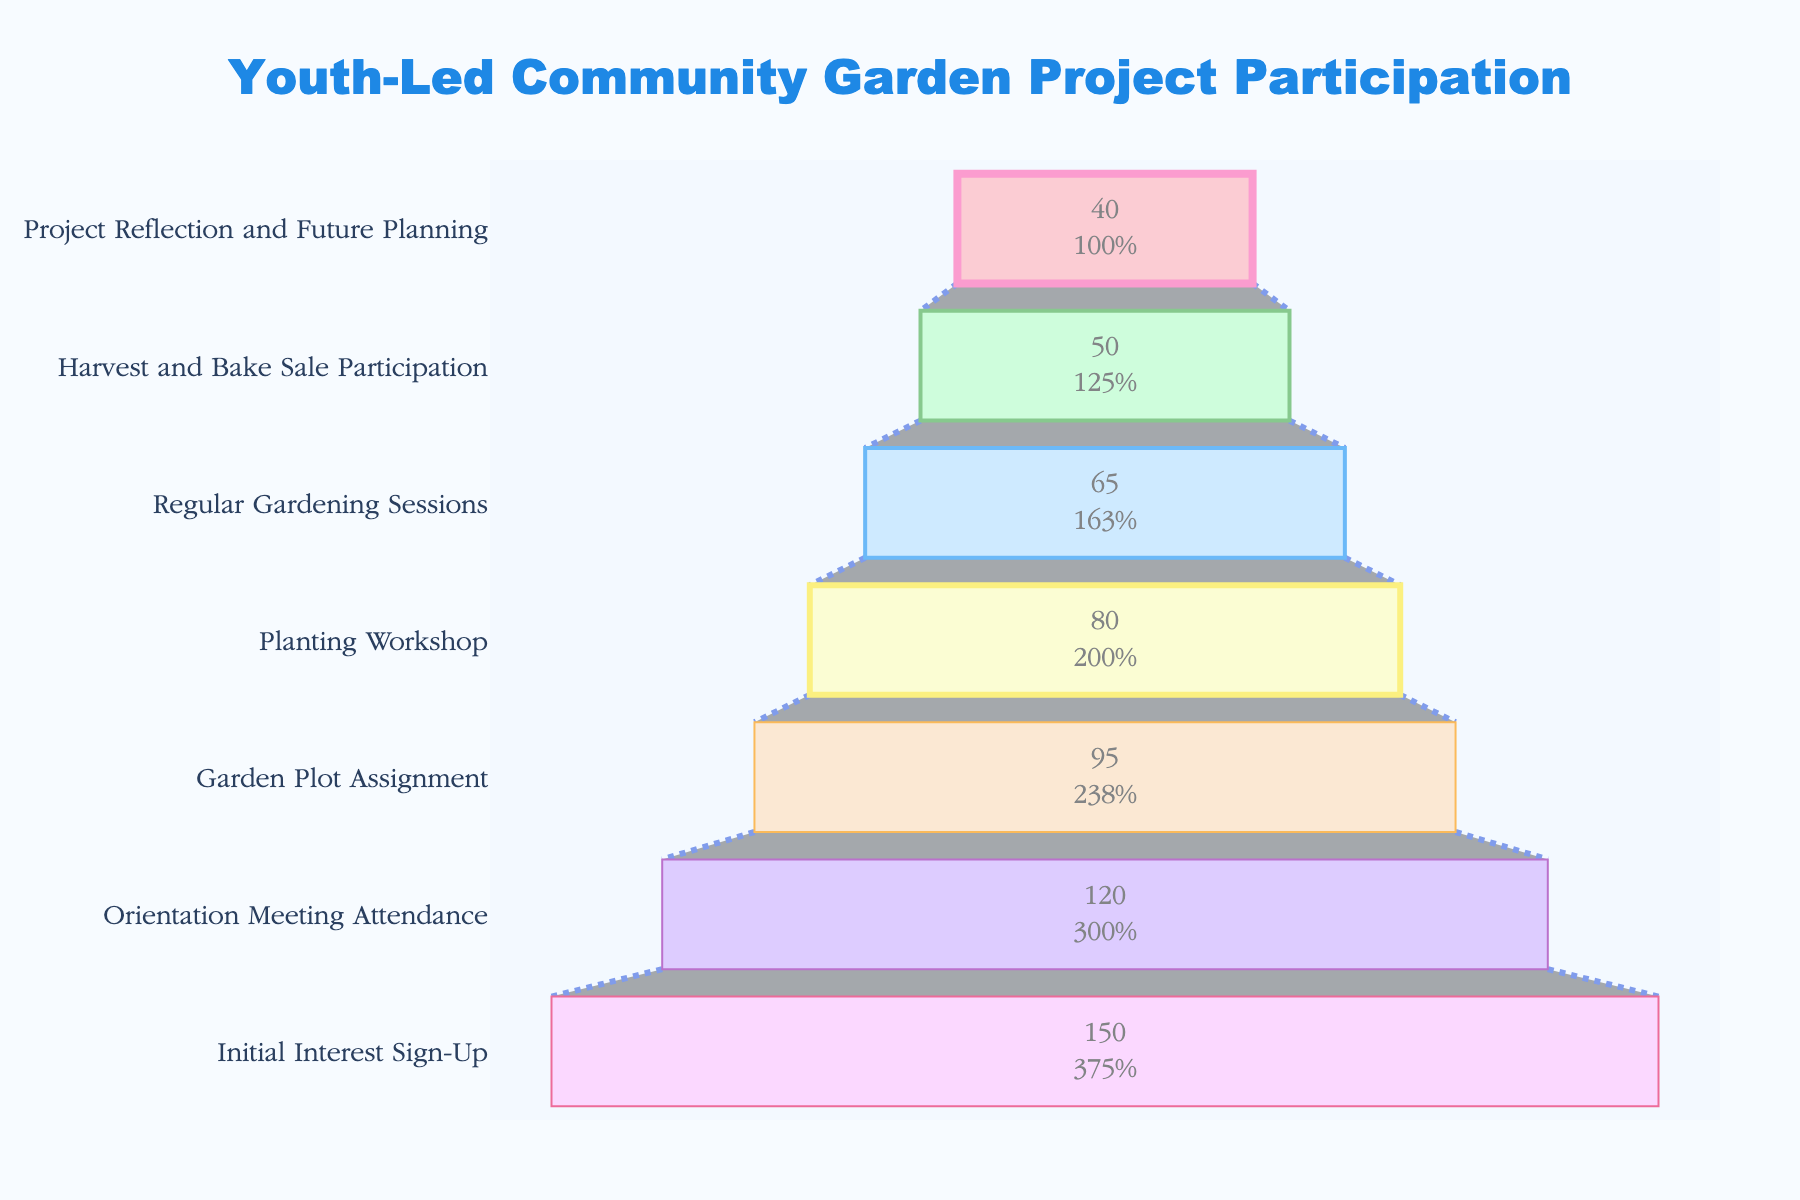What's the title of the chart? The title of the chart is prominently displayed at the top of the figure. It reads "Youth-Led Community Garden Project Participation".
Answer: "Youth-Led Community Garden Project Participation" How many participants attended the Orientation Meeting? The second stage from the top of the funnel chart shows the number of participants who attended the Orientation Meeting. It indicates 120 participants there.
Answer: 120 What is the percentage decrease in participants from the Orientation Meeting Attendance to the Garden Plot Assignment? First, find the number of participants at both stages: 120 (Orientation Meeting Attendance) and 95 (Garden Plot Assignment). The decrease is 120 - 95 = 25. To find the percentage decrease: (25/120) * 100 ≈ 20.83%.
Answer: ≈ 20.83% In which stage did the participation drop the most? By comparing the number of participants at each stage, the largest drop is observed from the Orientation Meeting Attendance (120 participants) to the Garden Plot Assignment (95 participants), a drop of 25 participants.
Answer: Orientation Meeting Attendance to Garden Plot Assignment Which stages have fewer than 70 participants? According to the figure, stages with fewer than 70 participants are Regular Gardening Sessions (65 participants), Harvest and Bake Sale Participation (50 participants), and Project Reflection and Future Planning (40 participants).
Answer: Regular Gardening Sessions, Harvest and Bake Sale Participation, Project Reflection and Future Planning What stage immediately follows the Initial Interest Sign-Up, and how many participants were there? The stage that follows Initial Interest Sign-Up is Orientation Meeting Attendance, which had 120 participants.
Answer: Orientation Meeting Attendance, 120 Which stage has the highest number of participants, and how many? The stage with the highest number of participants is the Initial Interest Sign-Up with 150 participants.
Answer: Initial Interest Sign-Up, 150 What's the average number of participants across all stages? Sum the number of participants for all stages: 150 + 120 + 95 + 80 + 65 + 50 + 40 = 600. Divide by the number of stages: 600 / 7 ≈ 85.71.
Answer: ≈ 85.71 How many participants were lost between the Planting Workshop and the Regular Gardening Sessions? The number of participants in the Planting Workshop is 80, and the number in Regular Gardening Sessions is 65. The loss is 80 - 65 = 15 participants.
Answer: 15 